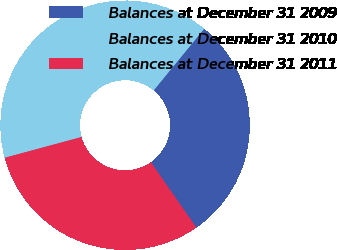<chart> <loc_0><loc_0><loc_500><loc_500><pie_chart><fcel>Balances at December 31 2009<fcel>Balances at December 31 2010<fcel>Balances at December 31 2011<nl><fcel>29.4%<fcel>40.13%<fcel>30.47%<nl></chart> 